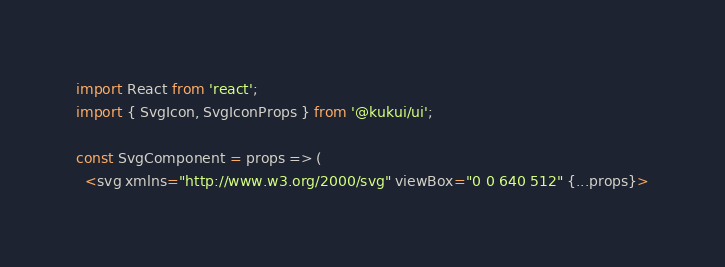<code> <loc_0><loc_0><loc_500><loc_500><_TypeScript_>import React from 'react';
import { SvgIcon, SvgIconProps } from '@kukui/ui';

const SvgComponent = props => (
  <svg xmlns="http://www.w3.org/2000/svg" viewBox="0 0 640 512" {...props}></code> 